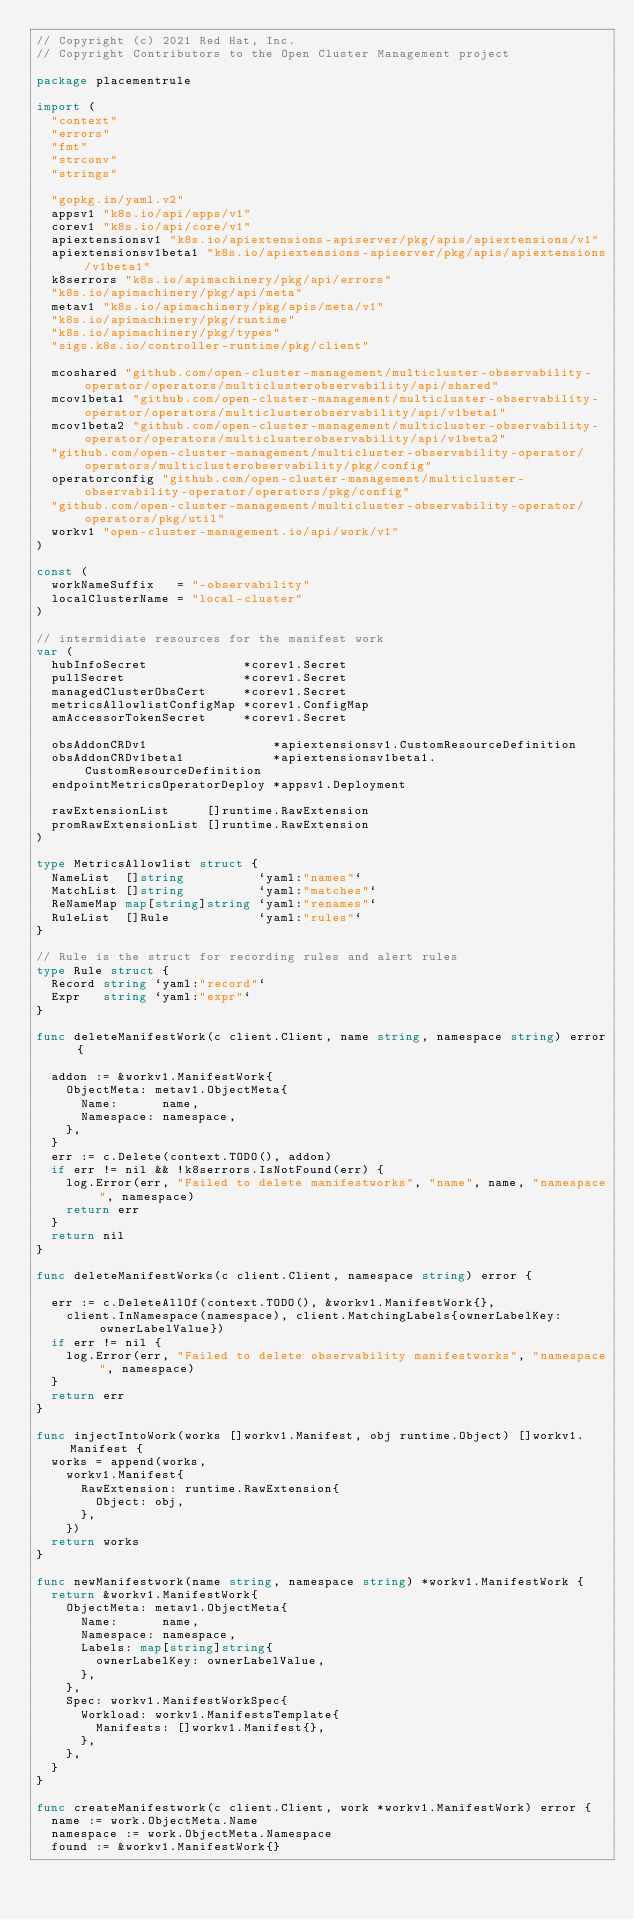<code> <loc_0><loc_0><loc_500><loc_500><_Go_>// Copyright (c) 2021 Red Hat, Inc.
// Copyright Contributors to the Open Cluster Management project

package placementrule

import (
	"context"
	"errors"
	"fmt"
	"strconv"
	"strings"

	"gopkg.in/yaml.v2"
	appsv1 "k8s.io/api/apps/v1"
	corev1 "k8s.io/api/core/v1"
	apiextensionsv1 "k8s.io/apiextensions-apiserver/pkg/apis/apiextensions/v1"
	apiextensionsv1beta1 "k8s.io/apiextensions-apiserver/pkg/apis/apiextensions/v1beta1"
	k8serrors "k8s.io/apimachinery/pkg/api/errors"
	"k8s.io/apimachinery/pkg/api/meta"
	metav1 "k8s.io/apimachinery/pkg/apis/meta/v1"
	"k8s.io/apimachinery/pkg/runtime"
	"k8s.io/apimachinery/pkg/types"
	"sigs.k8s.io/controller-runtime/pkg/client"

	mcoshared "github.com/open-cluster-management/multicluster-observability-operator/operators/multiclusterobservability/api/shared"
	mcov1beta1 "github.com/open-cluster-management/multicluster-observability-operator/operators/multiclusterobservability/api/v1beta1"
	mcov1beta2 "github.com/open-cluster-management/multicluster-observability-operator/operators/multiclusterobservability/api/v1beta2"
	"github.com/open-cluster-management/multicluster-observability-operator/operators/multiclusterobservability/pkg/config"
	operatorconfig "github.com/open-cluster-management/multicluster-observability-operator/operators/pkg/config"
	"github.com/open-cluster-management/multicluster-observability-operator/operators/pkg/util"
	workv1 "open-cluster-management.io/api/work/v1"
)

const (
	workNameSuffix   = "-observability"
	localClusterName = "local-cluster"
)

// intermidiate resources for the manifest work
var (
	hubInfoSecret             *corev1.Secret
	pullSecret                *corev1.Secret
	managedClusterObsCert     *corev1.Secret
	metricsAllowlistConfigMap *corev1.ConfigMap
	amAccessorTokenSecret     *corev1.Secret

	obsAddonCRDv1                 *apiextensionsv1.CustomResourceDefinition
	obsAddonCRDv1beta1            *apiextensionsv1beta1.CustomResourceDefinition
	endpointMetricsOperatorDeploy *appsv1.Deployment

	rawExtensionList     []runtime.RawExtension
	promRawExtensionList []runtime.RawExtension
)

type MetricsAllowlist struct {
	NameList  []string          `yaml:"names"`
	MatchList []string          `yaml:"matches"`
	ReNameMap map[string]string `yaml:"renames"`
	RuleList  []Rule            `yaml:"rules"`
}

// Rule is the struct for recording rules and alert rules
type Rule struct {
	Record string `yaml:"record"`
	Expr   string `yaml:"expr"`
}

func deleteManifestWork(c client.Client, name string, namespace string) error {

	addon := &workv1.ManifestWork{
		ObjectMeta: metav1.ObjectMeta{
			Name:      name,
			Namespace: namespace,
		},
	}
	err := c.Delete(context.TODO(), addon)
	if err != nil && !k8serrors.IsNotFound(err) {
		log.Error(err, "Failed to delete manifestworks", "name", name, "namespace", namespace)
		return err
	}
	return nil
}

func deleteManifestWorks(c client.Client, namespace string) error {

	err := c.DeleteAllOf(context.TODO(), &workv1.ManifestWork{},
		client.InNamespace(namespace), client.MatchingLabels{ownerLabelKey: ownerLabelValue})
	if err != nil {
		log.Error(err, "Failed to delete observability manifestworks", "namespace", namespace)
	}
	return err
}

func injectIntoWork(works []workv1.Manifest, obj runtime.Object) []workv1.Manifest {
	works = append(works,
		workv1.Manifest{
			RawExtension: runtime.RawExtension{
				Object: obj,
			},
		})
	return works
}

func newManifestwork(name string, namespace string) *workv1.ManifestWork {
	return &workv1.ManifestWork{
		ObjectMeta: metav1.ObjectMeta{
			Name:      name,
			Namespace: namespace,
			Labels: map[string]string{
				ownerLabelKey: ownerLabelValue,
			},
		},
		Spec: workv1.ManifestWorkSpec{
			Workload: workv1.ManifestsTemplate{
				Manifests: []workv1.Manifest{},
			},
		},
	}
}

func createManifestwork(c client.Client, work *workv1.ManifestWork) error {
	name := work.ObjectMeta.Name
	namespace := work.ObjectMeta.Namespace
	found := &workv1.ManifestWork{}</code> 